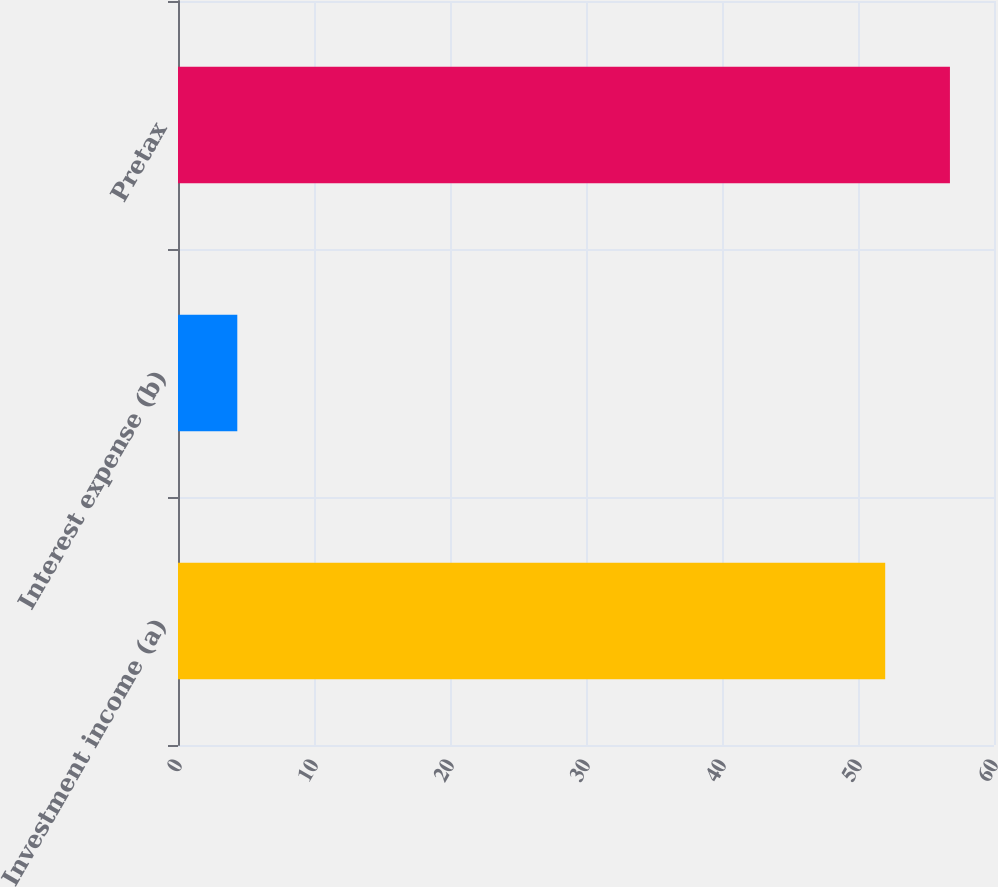Convert chart to OTSL. <chart><loc_0><loc_0><loc_500><loc_500><bar_chart><fcel>Investment income (a)<fcel>Interest expense (b)<fcel>Pretax<nl><fcel>52<fcel>4.36<fcel>56.76<nl></chart> 